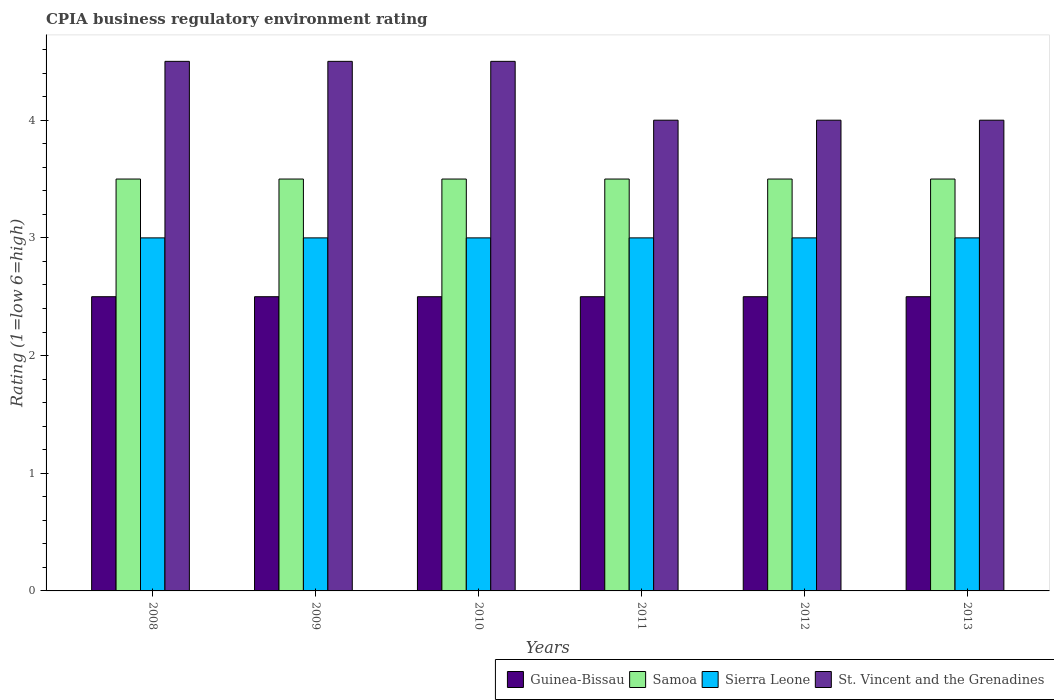How many different coloured bars are there?
Your answer should be compact. 4. How many bars are there on the 1st tick from the left?
Give a very brief answer. 4. How many bars are there on the 5th tick from the right?
Ensure brevity in your answer.  4. Across all years, what is the minimum CPIA rating in Guinea-Bissau?
Your answer should be very brief. 2.5. In which year was the CPIA rating in St. Vincent and the Grenadines maximum?
Offer a very short reply. 2008. In which year was the CPIA rating in St. Vincent and the Grenadines minimum?
Your response must be concise. 2011. What is the total CPIA rating in St. Vincent and the Grenadines in the graph?
Provide a succinct answer. 25.5. What is the difference between the CPIA rating in St. Vincent and the Grenadines in 2008 and that in 2011?
Offer a very short reply. 0.5. What is the average CPIA rating in Samoa per year?
Make the answer very short. 3.5. In how many years, is the CPIA rating in Samoa greater than 4.2?
Ensure brevity in your answer.  0. What is the ratio of the CPIA rating in Sierra Leone in 2010 to that in 2011?
Provide a succinct answer. 1. Is the CPIA rating in Sierra Leone in 2011 less than that in 2013?
Your answer should be very brief. No. Is the difference between the CPIA rating in St. Vincent and the Grenadines in 2008 and 2010 greater than the difference between the CPIA rating in Sierra Leone in 2008 and 2010?
Give a very brief answer. No. What is the difference between the highest and the lowest CPIA rating in Sierra Leone?
Your response must be concise. 0. In how many years, is the CPIA rating in Guinea-Bissau greater than the average CPIA rating in Guinea-Bissau taken over all years?
Your answer should be compact. 0. Is the sum of the CPIA rating in Samoa in 2010 and 2011 greater than the maximum CPIA rating in Sierra Leone across all years?
Your answer should be very brief. Yes. Is it the case that in every year, the sum of the CPIA rating in St. Vincent and the Grenadines and CPIA rating in Samoa is greater than the sum of CPIA rating in Guinea-Bissau and CPIA rating in Sierra Leone?
Offer a very short reply. Yes. What does the 4th bar from the left in 2013 represents?
Offer a terse response. St. Vincent and the Grenadines. What does the 4th bar from the right in 2011 represents?
Make the answer very short. Guinea-Bissau. Is it the case that in every year, the sum of the CPIA rating in St. Vincent and the Grenadines and CPIA rating in Samoa is greater than the CPIA rating in Guinea-Bissau?
Offer a terse response. Yes. How many years are there in the graph?
Give a very brief answer. 6. What is the difference between two consecutive major ticks on the Y-axis?
Make the answer very short. 1. Are the values on the major ticks of Y-axis written in scientific E-notation?
Your answer should be compact. No. Does the graph contain grids?
Provide a succinct answer. No. Where does the legend appear in the graph?
Provide a succinct answer. Bottom right. How many legend labels are there?
Ensure brevity in your answer.  4. How are the legend labels stacked?
Ensure brevity in your answer.  Horizontal. What is the title of the graph?
Keep it short and to the point. CPIA business regulatory environment rating. What is the label or title of the X-axis?
Your response must be concise. Years. What is the label or title of the Y-axis?
Offer a very short reply. Rating (1=low 6=high). What is the Rating (1=low 6=high) in Sierra Leone in 2008?
Offer a very short reply. 3. What is the Rating (1=low 6=high) in Guinea-Bissau in 2009?
Make the answer very short. 2.5. What is the Rating (1=low 6=high) of St. Vincent and the Grenadines in 2009?
Provide a short and direct response. 4.5. What is the Rating (1=low 6=high) in Guinea-Bissau in 2010?
Keep it short and to the point. 2.5. What is the Rating (1=low 6=high) of Samoa in 2010?
Offer a very short reply. 3.5. What is the Rating (1=low 6=high) in Sierra Leone in 2010?
Your answer should be compact. 3. What is the Rating (1=low 6=high) in St. Vincent and the Grenadines in 2010?
Your response must be concise. 4.5. What is the Rating (1=low 6=high) of Guinea-Bissau in 2011?
Make the answer very short. 2.5. What is the Rating (1=low 6=high) in Samoa in 2012?
Give a very brief answer. 3.5. What is the Rating (1=low 6=high) of Sierra Leone in 2012?
Provide a short and direct response. 3. What is the Rating (1=low 6=high) of St. Vincent and the Grenadines in 2012?
Your answer should be very brief. 4. What is the Rating (1=low 6=high) in Guinea-Bissau in 2013?
Give a very brief answer. 2.5. What is the Rating (1=low 6=high) in Samoa in 2013?
Offer a terse response. 3.5. What is the Rating (1=low 6=high) of Sierra Leone in 2013?
Ensure brevity in your answer.  3. Across all years, what is the maximum Rating (1=low 6=high) of Guinea-Bissau?
Ensure brevity in your answer.  2.5. Across all years, what is the maximum Rating (1=low 6=high) in Sierra Leone?
Ensure brevity in your answer.  3. Across all years, what is the minimum Rating (1=low 6=high) in Guinea-Bissau?
Provide a short and direct response. 2.5. What is the total Rating (1=low 6=high) in Guinea-Bissau in the graph?
Offer a terse response. 15. What is the total Rating (1=low 6=high) in St. Vincent and the Grenadines in the graph?
Provide a short and direct response. 25.5. What is the difference between the Rating (1=low 6=high) of Guinea-Bissau in 2008 and that in 2009?
Your response must be concise. 0. What is the difference between the Rating (1=low 6=high) in Samoa in 2008 and that in 2009?
Make the answer very short. 0. What is the difference between the Rating (1=low 6=high) of Guinea-Bissau in 2008 and that in 2010?
Offer a terse response. 0. What is the difference between the Rating (1=low 6=high) in St. Vincent and the Grenadines in 2008 and that in 2010?
Provide a short and direct response. 0. What is the difference between the Rating (1=low 6=high) of Sierra Leone in 2008 and that in 2011?
Your answer should be very brief. 0. What is the difference between the Rating (1=low 6=high) in St. Vincent and the Grenadines in 2008 and that in 2011?
Provide a short and direct response. 0.5. What is the difference between the Rating (1=low 6=high) of Guinea-Bissau in 2008 and that in 2012?
Keep it short and to the point. 0. What is the difference between the Rating (1=low 6=high) in St. Vincent and the Grenadines in 2008 and that in 2012?
Give a very brief answer. 0.5. What is the difference between the Rating (1=low 6=high) in Samoa in 2008 and that in 2013?
Ensure brevity in your answer.  0. What is the difference between the Rating (1=low 6=high) in St. Vincent and the Grenadines in 2008 and that in 2013?
Keep it short and to the point. 0.5. What is the difference between the Rating (1=low 6=high) of St. Vincent and the Grenadines in 2009 and that in 2010?
Make the answer very short. 0. What is the difference between the Rating (1=low 6=high) in Guinea-Bissau in 2009 and that in 2011?
Your answer should be very brief. 0. What is the difference between the Rating (1=low 6=high) of Sierra Leone in 2009 and that in 2011?
Your answer should be very brief. 0. What is the difference between the Rating (1=low 6=high) of Guinea-Bissau in 2009 and that in 2012?
Your answer should be compact. 0. What is the difference between the Rating (1=low 6=high) of St. Vincent and the Grenadines in 2009 and that in 2012?
Provide a succinct answer. 0.5. What is the difference between the Rating (1=low 6=high) in Samoa in 2009 and that in 2013?
Give a very brief answer. 0. What is the difference between the Rating (1=low 6=high) in St. Vincent and the Grenadines in 2009 and that in 2013?
Provide a succinct answer. 0.5. What is the difference between the Rating (1=low 6=high) in Samoa in 2010 and that in 2011?
Ensure brevity in your answer.  0. What is the difference between the Rating (1=low 6=high) in St. Vincent and the Grenadines in 2010 and that in 2011?
Provide a short and direct response. 0.5. What is the difference between the Rating (1=low 6=high) in Guinea-Bissau in 2010 and that in 2012?
Provide a succinct answer. 0. What is the difference between the Rating (1=low 6=high) of Sierra Leone in 2010 and that in 2012?
Offer a terse response. 0. What is the difference between the Rating (1=low 6=high) of Samoa in 2010 and that in 2013?
Keep it short and to the point. 0. What is the difference between the Rating (1=low 6=high) of Sierra Leone in 2010 and that in 2013?
Your answer should be compact. 0. What is the difference between the Rating (1=low 6=high) in Samoa in 2011 and that in 2012?
Your answer should be very brief. 0. What is the difference between the Rating (1=low 6=high) of Sierra Leone in 2011 and that in 2012?
Keep it short and to the point. 0. What is the difference between the Rating (1=low 6=high) in St. Vincent and the Grenadines in 2011 and that in 2012?
Provide a succinct answer. 0. What is the difference between the Rating (1=low 6=high) in Sierra Leone in 2011 and that in 2013?
Ensure brevity in your answer.  0. What is the difference between the Rating (1=low 6=high) of St. Vincent and the Grenadines in 2011 and that in 2013?
Offer a very short reply. 0. What is the difference between the Rating (1=low 6=high) of Guinea-Bissau in 2012 and that in 2013?
Offer a terse response. 0. What is the difference between the Rating (1=low 6=high) in Samoa in 2012 and that in 2013?
Keep it short and to the point. 0. What is the difference between the Rating (1=low 6=high) in St. Vincent and the Grenadines in 2012 and that in 2013?
Make the answer very short. 0. What is the difference between the Rating (1=low 6=high) of Guinea-Bissau in 2008 and the Rating (1=low 6=high) of Sierra Leone in 2009?
Give a very brief answer. -0.5. What is the difference between the Rating (1=low 6=high) of Guinea-Bissau in 2008 and the Rating (1=low 6=high) of St. Vincent and the Grenadines in 2009?
Your answer should be very brief. -2. What is the difference between the Rating (1=low 6=high) in Samoa in 2008 and the Rating (1=low 6=high) in Sierra Leone in 2009?
Give a very brief answer. 0.5. What is the difference between the Rating (1=low 6=high) of Sierra Leone in 2008 and the Rating (1=low 6=high) of St. Vincent and the Grenadines in 2009?
Your response must be concise. -1.5. What is the difference between the Rating (1=low 6=high) in Guinea-Bissau in 2008 and the Rating (1=low 6=high) in Sierra Leone in 2010?
Make the answer very short. -0.5. What is the difference between the Rating (1=low 6=high) in Guinea-Bissau in 2008 and the Rating (1=low 6=high) in St. Vincent and the Grenadines in 2010?
Give a very brief answer. -2. What is the difference between the Rating (1=low 6=high) in Samoa in 2008 and the Rating (1=low 6=high) in Sierra Leone in 2010?
Make the answer very short. 0.5. What is the difference between the Rating (1=low 6=high) in Samoa in 2008 and the Rating (1=low 6=high) in St. Vincent and the Grenadines in 2010?
Ensure brevity in your answer.  -1. What is the difference between the Rating (1=low 6=high) in Guinea-Bissau in 2008 and the Rating (1=low 6=high) in Samoa in 2011?
Your response must be concise. -1. What is the difference between the Rating (1=low 6=high) of Samoa in 2008 and the Rating (1=low 6=high) of St. Vincent and the Grenadines in 2011?
Offer a very short reply. -0.5. What is the difference between the Rating (1=low 6=high) of Sierra Leone in 2008 and the Rating (1=low 6=high) of St. Vincent and the Grenadines in 2011?
Ensure brevity in your answer.  -1. What is the difference between the Rating (1=low 6=high) of Guinea-Bissau in 2008 and the Rating (1=low 6=high) of Samoa in 2012?
Provide a succinct answer. -1. What is the difference between the Rating (1=low 6=high) of Guinea-Bissau in 2008 and the Rating (1=low 6=high) of Sierra Leone in 2012?
Offer a very short reply. -0.5. What is the difference between the Rating (1=low 6=high) in Guinea-Bissau in 2008 and the Rating (1=low 6=high) in St. Vincent and the Grenadines in 2012?
Keep it short and to the point. -1.5. What is the difference between the Rating (1=low 6=high) of Samoa in 2008 and the Rating (1=low 6=high) of St. Vincent and the Grenadines in 2012?
Offer a terse response. -0.5. What is the difference between the Rating (1=low 6=high) in Guinea-Bissau in 2008 and the Rating (1=low 6=high) in Samoa in 2013?
Provide a short and direct response. -1. What is the difference between the Rating (1=low 6=high) in Guinea-Bissau in 2008 and the Rating (1=low 6=high) in St. Vincent and the Grenadines in 2013?
Keep it short and to the point. -1.5. What is the difference between the Rating (1=low 6=high) of Samoa in 2008 and the Rating (1=low 6=high) of St. Vincent and the Grenadines in 2013?
Ensure brevity in your answer.  -0.5. What is the difference between the Rating (1=low 6=high) in Guinea-Bissau in 2009 and the Rating (1=low 6=high) in Samoa in 2010?
Your answer should be compact. -1. What is the difference between the Rating (1=low 6=high) in Guinea-Bissau in 2009 and the Rating (1=low 6=high) in Sierra Leone in 2010?
Your answer should be very brief. -0.5. What is the difference between the Rating (1=low 6=high) in Samoa in 2009 and the Rating (1=low 6=high) in Sierra Leone in 2010?
Your answer should be compact. 0.5. What is the difference between the Rating (1=low 6=high) in Samoa in 2009 and the Rating (1=low 6=high) in Sierra Leone in 2011?
Make the answer very short. 0.5. What is the difference between the Rating (1=low 6=high) in Samoa in 2009 and the Rating (1=low 6=high) in St. Vincent and the Grenadines in 2011?
Provide a succinct answer. -0.5. What is the difference between the Rating (1=low 6=high) of Sierra Leone in 2009 and the Rating (1=low 6=high) of St. Vincent and the Grenadines in 2011?
Your response must be concise. -1. What is the difference between the Rating (1=low 6=high) of Guinea-Bissau in 2009 and the Rating (1=low 6=high) of St. Vincent and the Grenadines in 2012?
Provide a short and direct response. -1.5. What is the difference between the Rating (1=low 6=high) of Samoa in 2009 and the Rating (1=low 6=high) of Sierra Leone in 2012?
Your response must be concise. 0.5. What is the difference between the Rating (1=low 6=high) of Samoa in 2009 and the Rating (1=low 6=high) of St. Vincent and the Grenadines in 2012?
Your answer should be compact. -0.5. What is the difference between the Rating (1=low 6=high) of Guinea-Bissau in 2009 and the Rating (1=low 6=high) of Sierra Leone in 2013?
Your answer should be compact. -0.5. What is the difference between the Rating (1=low 6=high) in Guinea-Bissau in 2009 and the Rating (1=low 6=high) in St. Vincent and the Grenadines in 2013?
Make the answer very short. -1.5. What is the difference between the Rating (1=low 6=high) of Samoa in 2009 and the Rating (1=low 6=high) of Sierra Leone in 2013?
Provide a succinct answer. 0.5. What is the difference between the Rating (1=low 6=high) in Guinea-Bissau in 2010 and the Rating (1=low 6=high) in Samoa in 2011?
Offer a very short reply. -1. What is the difference between the Rating (1=low 6=high) of Guinea-Bissau in 2010 and the Rating (1=low 6=high) of Sierra Leone in 2011?
Keep it short and to the point. -0.5. What is the difference between the Rating (1=low 6=high) in Guinea-Bissau in 2010 and the Rating (1=low 6=high) in St. Vincent and the Grenadines in 2011?
Provide a short and direct response. -1.5. What is the difference between the Rating (1=low 6=high) of Samoa in 2010 and the Rating (1=low 6=high) of Sierra Leone in 2011?
Give a very brief answer. 0.5. What is the difference between the Rating (1=low 6=high) in Guinea-Bissau in 2010 and the Rating (1=low 6=high) in Samoa in 2012?
Your response must be concise. -1. What is the difference between the Rating (1=low 6=high) of Guinea-Bissau in 2010 and the Rating (1=low 6=high) of Sierra Leone in 2012?
Offer a very short reply. -0.5. What is the difference between the Rating (1=low 6=high) of Samoa in 2010 and the Rating (1=low 6=high) of Sierra Leone in 2012?
Your answer should be compact. 0.5. What is the difference between the Rating (1=low 6=high) of Guinea-Bissau in 2010 and the Rating (1=low 6=high) of Sierra Leone in 2013?
Your answer should be very brief. -0.5. What is the difference between the Rating (1=low 6=high) of Samoa in 2010 and the Rating (1=low 6=high) of Sierra Leone in 2013?
Offer a very short reply. 0.5. What is the difference between the Rating (1=low 6=high) in Guinea-Bissau in 2011 and the Rating (1=low 6=high) in Sierra Leone in 2012?
Give a very brief answer. -0.5. What is the difference between the Rating (1=low 6=high) in Guinea-Bissau in 2011 and the Rating (1=low 6=high) in Samoa in 2013?
Provide a short and direct response. -1. What is the difference between the Rating (1=low 6=high) of Guinea-Bissau in 2011 and the Rating (1=low 6=high) of St. Vincent and the Grenadines in 2013?
Your answer should be very brief. -1.5. What is the difference between the Rating (1=low 6=high) in Samoa in 2011 and the Rating (1=low 6=high) in Sierra Leone in 2013?
Ensure brevity in your answer.  0.5. What is the difference between the Rating (1=low 6=high) of Guinea-Bissau in 2012 and the Rating (1=low 6=high) of St. Vincent and the Grenadines in 2013?
Offer a terse response. -1.5. What is the difference between the Rating (1=low 6=high) of Samoa in 2012 and the Rating (1=low 6=high) of Sierra Leone in 2013?
Offer a very short reply. 0.5. What is the difference between the Rating (1=low 6=high) of Samoa in 2012 and the Rating (1=low 6=high) of St. Vincent and the Grenadines in 2013?
Offer a very short reply. -0.5. What is the difference between the Rating (1=low 6=high) of Sierra Leone in 2012 and the Rating (1=low 6=high) of St. Vincent and the Grenadines in 2013?
Give a very brief answer. -1. What is the average Rating (1=low 6=high) of Sierra Leone per year?
Offer a very short reply. 3. What is the average Rating (1=low 6=high) of St. Vincent and the Grenadines per year?
Provide a succinct answer. 4.25. In the year 2008, what is the difference between the Rating (1=low 6=high) in Guinea-Bissau and Rating (1=low 6=high) in St. Vincent and the Grenadines?
Your response must be concise. -2. In the year 2008, what is the difference between the Rating (1=low 6=high) of Samoa and Rating (1=low 6=high) of St. Vincent and the Grenadines?
Provide a succinct answer. -1. In the year 2008, what is the difference between the Rating (1=low 6=high) of Sierra Leone and Rating (1=low 6=high) of St. Vincent and the Grenadines?
Offer a very short reply. -1.5. In the year 2009, what is the difference between the Rating (1=low 6=high) in Guinea-Bissau and Rating (1=low 6=high) in Samoa?
Keep it short and to the point. -1. In the year 2009, what is the difference between the Rating (1=low 6=high) of Samoa and Rating (1=low 6=high) of Sierra Leone?
Give a very brief answer. 0.5. In the year 2009, what is the difference between the Rating (1=low 6=high) of Sierra Leone and Rating (1=low 6=high) of St. Vincent and the Grenadines?
Your response must be concise. -1.5. In the year 2010, what is the difference between the Rating (1=low 6=high) of Guinea-Bissau and Rating (1=low 6=high) of Samoa?
Provide a succinct answer. -1. In the year 2010, what is the difference between the Rating (1=low 6=high) in Guinea-Bissau and Rating (1=low 6=high) in Sierra Leone?
Offer a terse response. -0.5. In the year 2010, what is the difference between the Rating (1=low 6=high) of Guinea-Bissau and Rating (1=low 6=high) of St. Vincent and the Grenadines?
Offer a terse response. -2. In the year 2010, what is the difference between the Rating (1=low 6=high) of Samoa and Rating (1=low 6=high) of St. Vincent and the Grenadines?
Keep it short and to the point. -1. In the year 2010, what is the difference between the Rating (1=low 6=high) in Sierra Leone and Rating (1=low 6=high) in St. Vincent and the Grenadines?
Offer a very short reply. -1.5. In the year 2011, what is the difference between the Rating (1=low 6=high) of Guinea-Bissau and Rating (1=low 6=high) of Sierra Leone?
Ensure brevity in your answer.  -0.5. In the year 2011, what is the difference between the Rating (1=low 6=high) of Sierra Leone and Rating (1=low 6=high) of St. Vincent and the Grenadines?
Ensure brevity in your answer.  -1. In the year 2012, what is the difference between the Rating (1=low 6=high) of Sierra Leone and Rating (1=low 6=high) of St. Vincent and the Grenadines?
Give a very brief answer. -1. In the year 2013, what is the difference between the Rating (1=low 6=high) of Guinea-Bissau and Rating (1=low 6=high) of Sierra Leone?
Provide a short and direct response. -0.5. What is the ratio of the Rating (1=low 6=high) of Samoa in 2008 to that in 2009?
Give a very brief answer. 1. What is the ratio of the Rating (1=low 6=high) in Sierra Leone in 2008 to that in 2009?
Offer a terse response. 1. What is the ratio of the Rating (1=low 6=high) in Samoa in 2008 to that in 2010?
Your answer should be very brief. 1. What is the ratio of the Rating (1=low 6=high) in Samoa in 2008 to that in 2011?
Offer a very short reply. 1. What is the ratio of the Rating (1=low 6=high) in Sierra Leone in 2008 to that in 2011?
Give a very brief answer. 1. What is the ratio of the Rating (1=low 6=high) of Guinea-Bissau in 2008 to that in 2012?
Offer a terse response. 1. What is the ratio of the Rating (1=low 6=high) in Samoa in 2008 to that in 2012?
Your response must be concise. 1. What is the ratio of the Rating (1=low 6=high) in Sierra Leone in 2008 to that in 2012?
Make the answer very short. 1. What is the ratio of the Rating (1=low 6=high) of St. Vincent and the Grenadines in 2008 to that in 2013?
Offer a terse response. 1.12. What is the ratio of the Rating (1=low 6=high) in Guinea-Bissau in 2009 to that in 2010?
Make the answer very short. 1. What is the ratio of the Rating (1=low 6=high) in Guinea-Bissau in 2009 to that in 2011?
Ensure brevity in your answer.  1. What is the ratio of the Rating (1=low 6=high) of Samoa in 2009 to that in 2011?
Your response must be concise. 1. What is the ratio of the Rating (1=low 6=high) in Guinea-Bissau in 2009 to that in 2012?
Make the answer very short. 1. What is the ratio of the Rating (1=low 6=high) in Samoa in 2009 to that in 2012?
Give a very brief answer. 1. What is the ratio of the Rating (1=low 6=high) in Sierra Leone in 2009 to that in 2012?
Keep it short and to the point. 1. What is the ratio of the Rating (1=low 6=high) in St. Vincent and the Grenadines in 2009 to that in 2012?
Keep it short and to the point. 1.12. What is the ratio of the Rating (1=low 6=high) in Samoa in 2009 to that in 2013?
Provide a short and direct response. 1. What is the ratio of the Rating (1=low 6=high) in Sierra Leone in 2009 to that in 2013?
Ensure brevity in your answer.  1. What is the ratio of the Rating (1=low 6=high) of St. Vincent and the Grenadines in 2010 to that in 2011?
Make the answer very short. 1.12. What is the ratio of the Rating (1=low 6=high) in Sierra Leone in 2010 to that in 2012?
Give a very brief answer. 1. What is the ratio of the Rating (1=low 6=high) in Samoa in 2010 to that in 2013?
Provide a short and direct response. 1. What is the ratio of the Rating (1=low 6=high) of Samoa in 2011 to that in 2012?
Your answer should be compact. 1. What is the ratio of the Rating (1=low 6=high) of Guinea-Bissau in 2011 to that in 2013?
Ensure brevity in your answer.  1. What is the ratio of the Rating (1=low 6=high) in Sierra Leone in 2011 to that in 2013?
Give a very brief answer. 1. What is the ratio of the Rating (1=low 6=high) in Guinea-Bissau in 2012 to that in 2013?
Your response must be concise. 1. What is the ratio of the Rating (1=low 6=high) of Sierra Leone in 2012 to that in 2013?
Your answer should be very brief. 1. What is the ratio of the Rating (1=low 6=high) of St. Vincent and the Grenadines in 2012 to that in 2013?
Give a very brief answer. 1. What is the difference between the highest and the second highest Rating (1=low 6=high) of Guinea-Bissau?
Make the answer very short. 0. What is the difference between the highest and the second highest Rating (1=low 6=high) in Samoa?
Give a very brief answer. 0. What is the difference between the highest and the second highest Rating (1=low 6=high) of Sierra Leone?
Ensure brevity in your answer.  0. What is the difference between the highest and the second highest Rating (1=low 6=high) of St. Vincent and the Grenadines?
Your answer should be compact. 0. What is the difference between the highest and the lowest Rating (1=low 6=high) in Sierra Leone?
Provide a succinct answer. 0. 